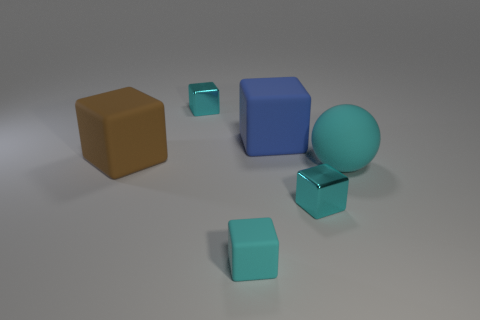Do the matte sphere and the tiny rubber thing have the same color?
Your response must be concise. Yes. Does the tiny cyan matte thing have the same shape as the rubber object behind the large brown object?
Give a very brief answer. Yes. How many blue matte things are to the left of the small metal object that is behind the blue rubber block?
Provide a short and direct response. 0. There is another large thing that is the same shape as the blue thing; what is it made of?
Provide a short and direct response. Rubber. How many blue things are big blocks or big objects?
Your response must be concise. 1. Are there any other things of the same color as the ball?
Offer a terse response. Yes. What color is the tiny metallic cube that is in front of the small metal block behind the large brown block?
Offer a very short reply. Cyan. Are there fewer small cyan rubber cubes that are on the left side of the big brown matte cube than blue matte blocks that are behind the large blue object?
Make the answer very short. No. There is a big thing that is the same color as the small rubber object; what is it made of?
Your answer should be compact. Rubber. What number of things are either small objects to the left of the big blue matte thing or small cyan matte blocks?
Give a very brief answer. 2. 